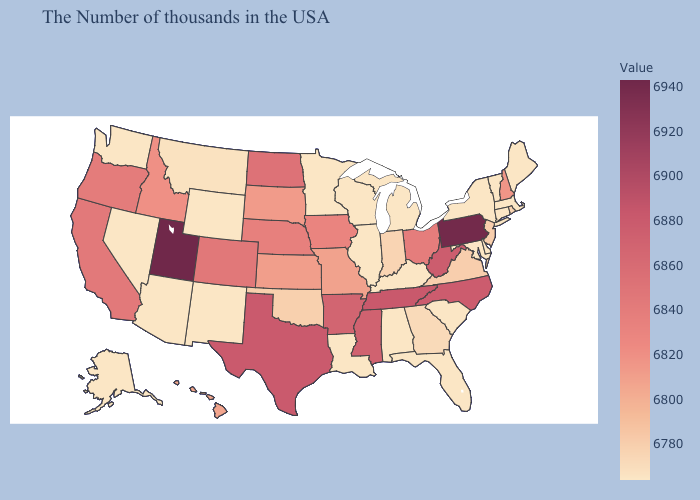Does Rhode Island have the lowest value in the Northeast?
Write a very short answer. No. Among the states that border Idaho , which have the highest value?
Answer briefly. Utah. Is the legend a continuous bar?
Be succinct. Yes. Does Washington have the lowest value in the West?
Short answer required. Yes. Which states have the lowest value in the MidWest?
Short answer required. Michigan, Wisconsin, Illinois, Minnesota. Which states have the highest value in the USA?
Keep it brief. Utah. Among the states that border Louisiana , does Arkansas have the lowest value?
Be succinct. Yes. Which states have the lowest value in the USA?
Concise answer only. Maine, Massachusetts, Vermont, Connecticut, New York, Delaware, Maryland, South Carolina, Florida, Michigan, Kentucky, Alabama, Wisconsin, Illinois, Louisiana, Minnesota, Wyoming, New Mexico, Arizona, Nevada, Washington, Alaska. 